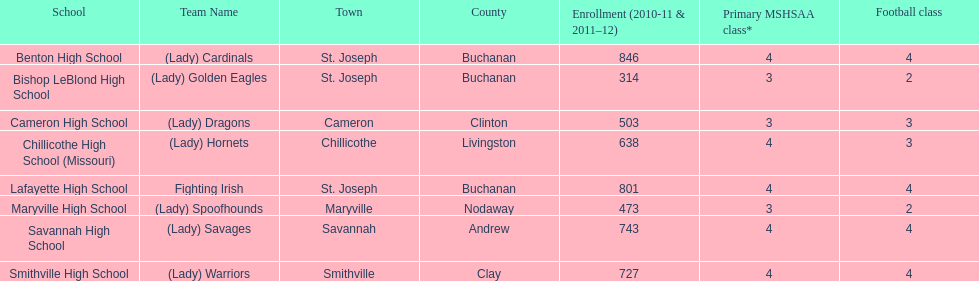In which school can you find three football classes being offered while having only 638 students enrolled? Chillicothe High School (Missouri). Can you parse all the data within this table? {'header': ['School', 'Team Name', 'Town', 'County', 'Enrollment (2010-11 & 2011–12)', 'Primary MSHSAA class*', 'Football class'], 'rows': [['Benton High School', '(Lady) Cardinals', 'St. Joseph', 'Buchanan', '846', '4', '4'], ['Bishop LeBlond High School', '(Lady) Golden Eagles', 'St. Joseph', 'Buchanan', '314', '3', '2'], ['Cameron High School', '(Lady) Dragons', 'Cameron', 'Clinton', '503', '3', '3'], ['Chillicothe High School (Missouri)', '(Lady) Hornets', 'Chillicothe', 'Livingston', '638', '4', '3'], ['Lafayette High School', 'Fighting Irish', 'St. Joseph', 'Buchanan', '801', '4', '4'], ['Maryville High School', '(Lady) Spoofhounds', 'Maryville', 'Nodaway', '473', '3', '2'], ['Savannah High School', '(Lady) Savages', 'Savannah', 'Andrew', '743', '4', '4'], ['Smithville High School', '(Lady) Warriors', 'Smithville', 'Clay', '727', '4', '4']]} 